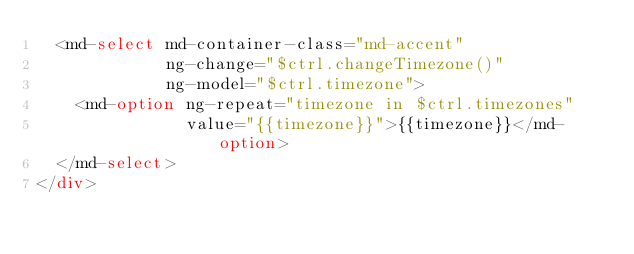<code> <loc_0><loc_0><loc_500><loc_500><_HTML_>  <md-select md-container-class="md-accent"
             ng-change="$ctrl.changeTimezone()"
             ng-model="$ctrl.timezone">
    <md-option ng-repeat="timezone in $ctrl.timezones"
               value="{{timezone}}">{{timezone}}</md-option>
  </md-select>
</div>
</code> 